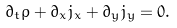<formula> <loc_0><loc_0><loc_500><loc_500>\partial _ { t } \rho + \partial _ { x } j _ { x } + \partial _ { y } j _ { y } = 0 .</formula> 